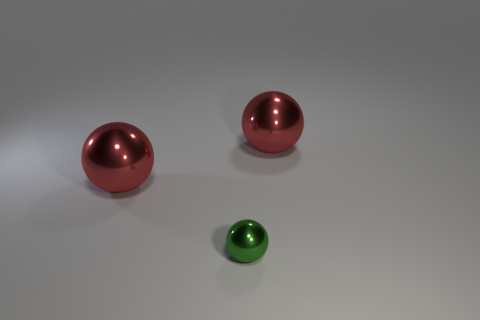Add 3 gray rubber cylinders. How many objects exist? 6 Subtract all red spheres. How many were subtracted if there are1red spheres left? 1 Subtract 2 balls. How many balls are left? 1 Subtract all gray spheres. Subtract all purple blocks. How many spheres are left? 3 Subtract all brown cylinders. How many cyan spheres are left? 0 Subtract all red balls. Subtract all small green spheres. How many objects are left? 0 Add 1 big balls. How many big balls are left? 3 Add 3 tiny purple shiny cylinders. How many tiny purple shiny cylinders exist? 3 Subtract all green balls. How many balls are left? 2 Subtract all tiny spheres. How many spheres are left? 2 